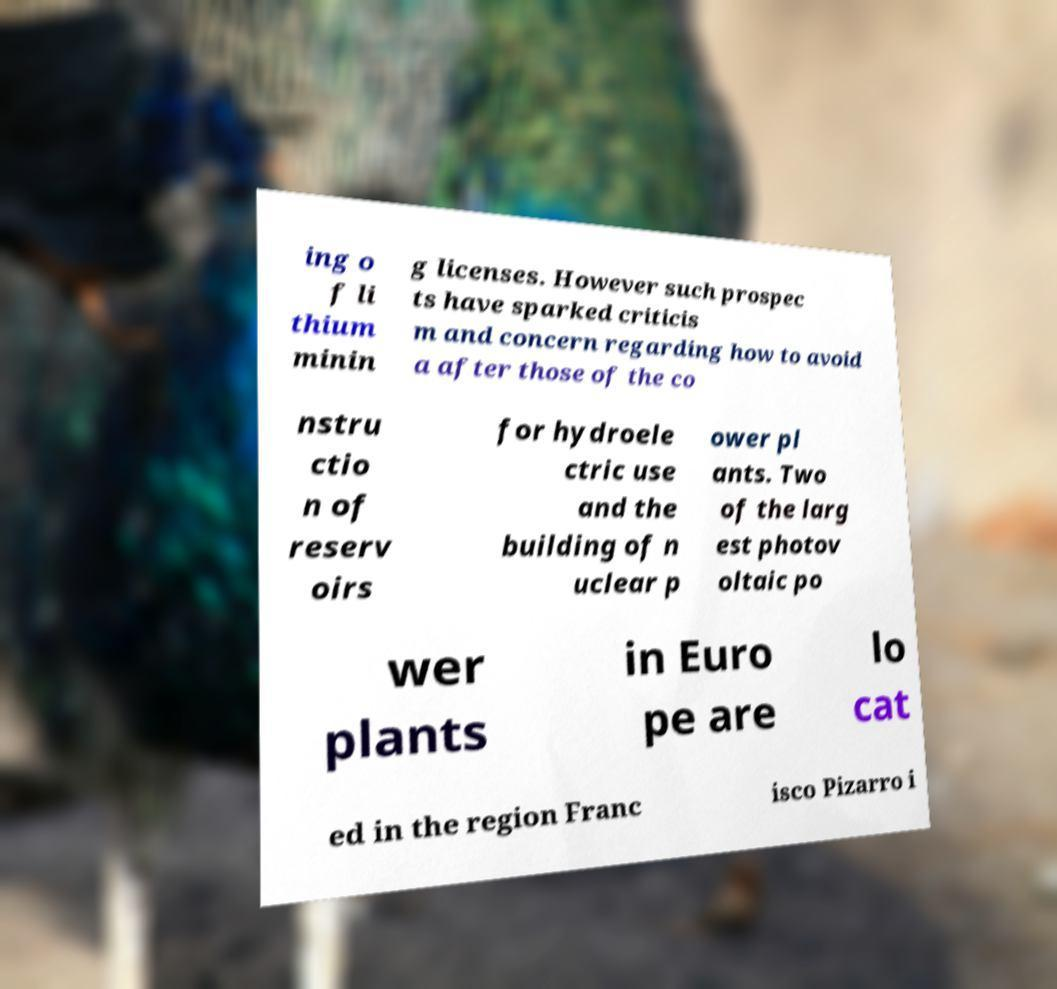I need the written content from this picture converted into text. Can you do that? ing o f li thium minin g licenses. However such prospec ts have sparked criticis m and concern regarding how to avoid a after those of the co nstru ctio n of reserv oirs for hydroele ctric use and the building of n uclear p ower pl ants. Two of the larg est photov oltaic po wer plants in Euro pe are lo cat ed in the region Franc isco Pizarro i 